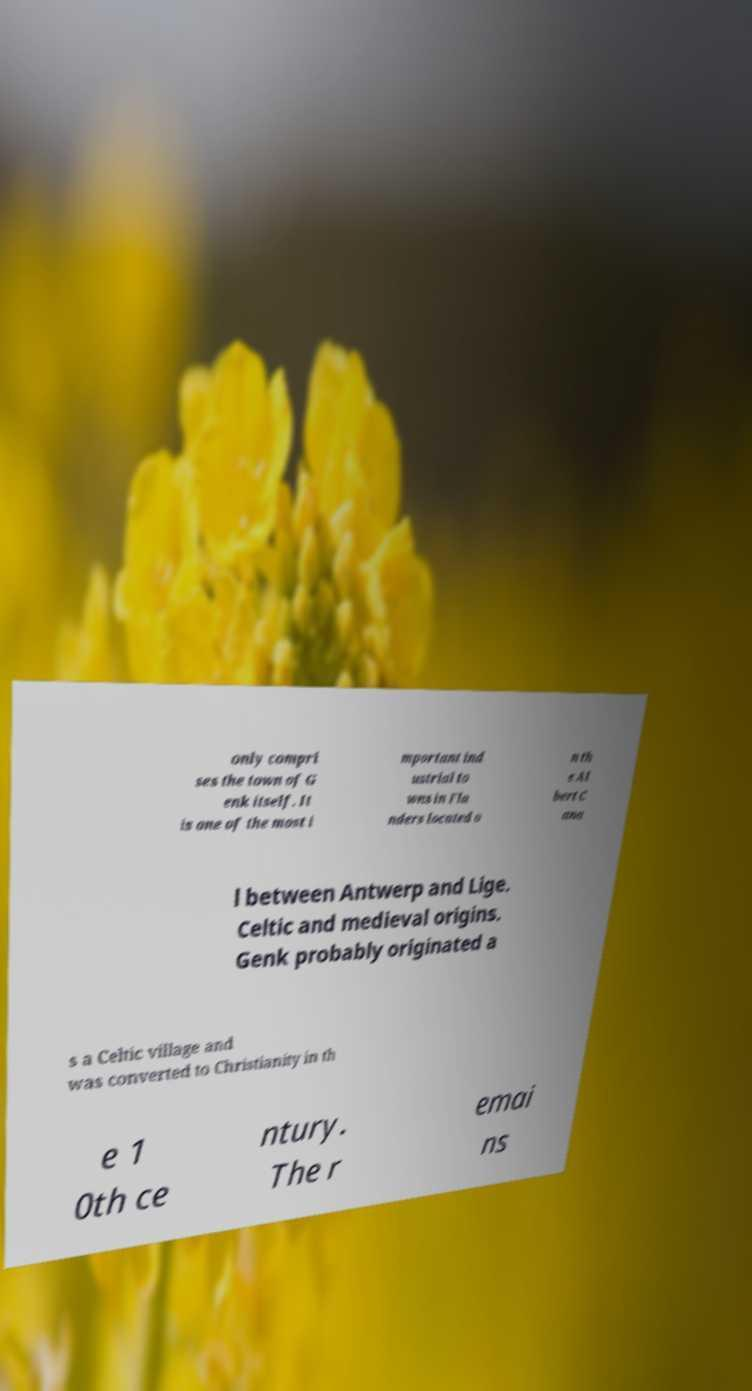I need the written content from this picture converted into text. Can you do that? only compri ses the town of G enk itself. It is one of the most i mportant ind ustrial to wns in Fla nders located o n th e Al bert C ana l between Antwerp and Lige. Celtic and medieval origins. Genk probably originated a s a Celtic village and was converted to Christianity in th e 1 0th ce ntury. The r emai ns 